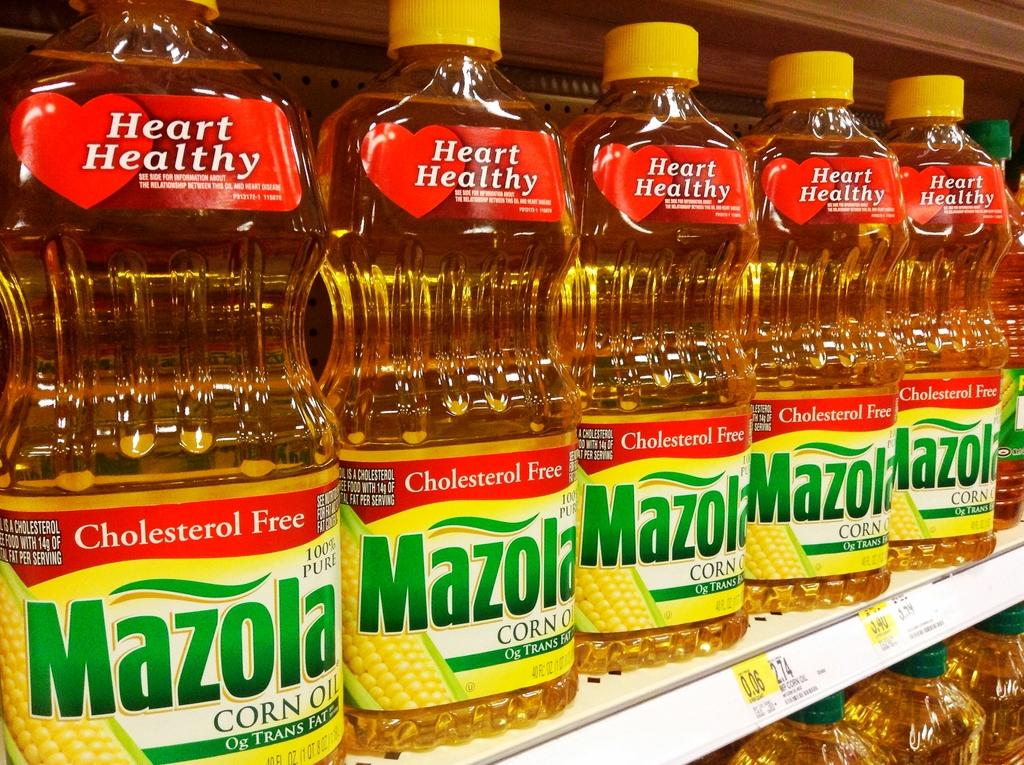<image>
Relay a brief, clear account of the picture shown. A picture of Mazola Corn oil bottles lined up on a store shelf. 